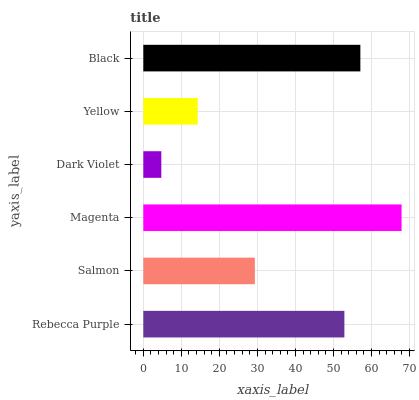Is Dark Violet the minimum?
Answer yes or no. Yes. Is Magenta the maximum?
Answer yes or no. Yes. Is Salmon the minimum?
Answer yes or no. No. Is Salmon the maximum?
Answer yes or no. No. Is Rebecca Purple greater than Salmon?
Answer yes or no. Yes. Is Salmon less than Rebecca Purple?
Answer yes or no. Yes. Is Salmon greater than Rebecca Purple?
Answer yes or no. No. Is Rebecca Purple less than Salmon?
Answer yes or no. No. Is Rebecca Purple the high median?
Answer yes or no. Yes. Is Salmon the low median?
Answer yes or no. Yes. Is Yellow the high median?
Answer yes or no. No. Is Magenta the low median?
Answer yes or no. No. 